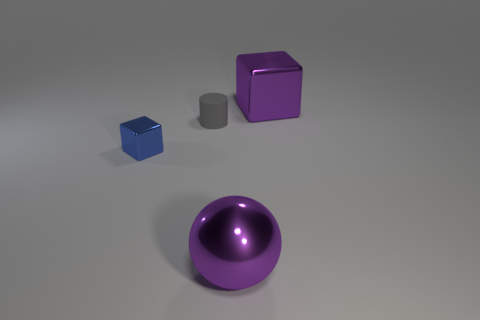Add 2 big yellow rubber things. How many objects exist? 6 Subtract all purple cubes. How many cubes are left? 1 Add 2 small cyan metal cubes. How many small cyan metal cubes exist? 2 Subtract 0 cyan cubes. How many objects are left? 4 Subtract all cylinders. How many objects are left? 3 Subtract 1 cylinders. How many cylinders are left? 0 Subtract all blue blocks. Subtract all gray cylinders. How many blocks are left? 1 Subtract all large purple balls. Subtract all tiny gray objects. How many objects are left? 2 Add 4 large purple things. How many large purple things are left? 6 